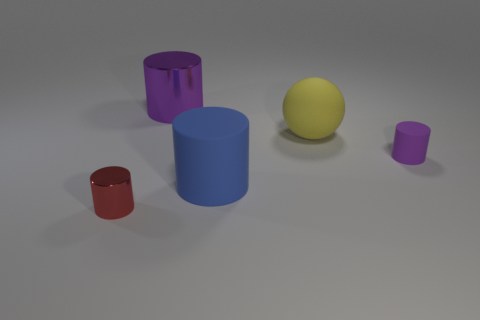Does the large metal thing have the same color as the rubber cylinder that is behind the large blue rubber cylinder?
Your answer should be compact. Yes. How many objects are large cyan rubber objects or matte objects that are in front of the purple matte cylinder?
Your response must be concise. 1. The other cylinder that is the same color as the small matte cylinder is what size?
Give a very brief answer. Large. What shape is the large object that is on the left side of the large blue object?
Provide a short and direct response. Cylinder. There is a matte object right of the large sphere; does it have the same color as the sphere?
Provide a short and direct response. No. There is a big thing that is the same color as the tiny matte object; what is it made of?
Offer a terse response. Metal. Does the shiny thing in front of the blue cylinder have the same size as the big blue thing?
Offer a terse response. No. Is there a cylinder of the same color as the tiny rubber thing?
Provide a short and direct response. Yes. There is a purple object that is to the right of the yellow object; are there any big rubber cylinders in front of it?
Ensure brevity in your answer.  Yes. Are there any small cylinders that have the same material as the large ball?
Your answer should be compact. Yes. 